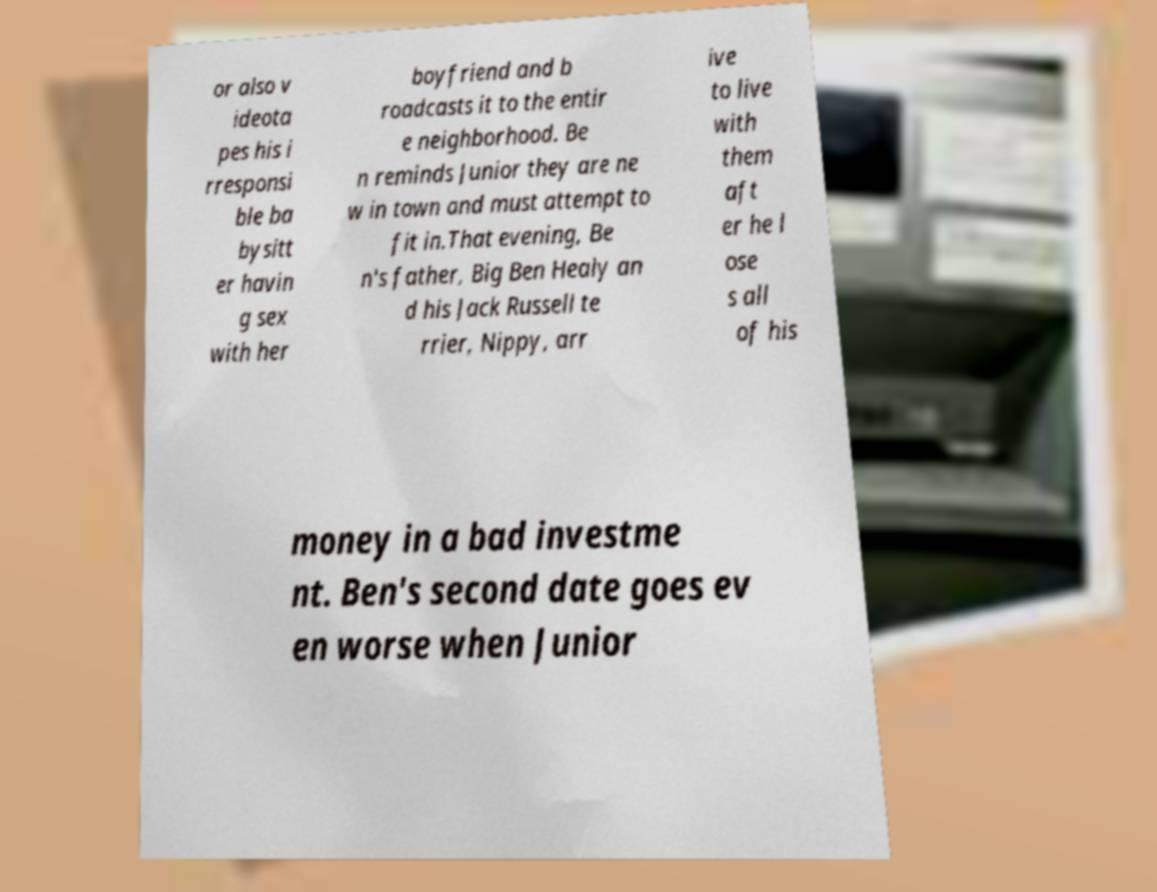Please identify and transcribe the text found in this image. or also v ideota pes his i rresponsi ble ba bysitt er havin g sex with her boyfriend and b roadcasts it to the entir e neighborhood. Be n reminds Junior they are ne w in town and must attempt to fit in.That evening, Be n's father, Big Ben Healy an d his Jack Russell te rrier, Nippy, arr ive to live with them aft er he l ose s all of his money in a bad investme nt. Ben's second date goes ev en worse when Junior 